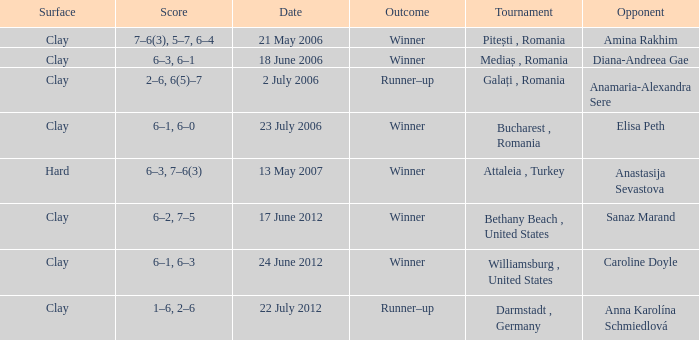Parse the full table. {'header': ['Surface', 'Score', 'Date', 'Outcome', 'Tournament', 'Opponent'], 'rows': [['Clay', '7–6(3), 5–7, 6–4', '21 May 2006', 'Winner', 'Pitești , Romania', 'Amina Rakhim'], ['Clay', '6–3, 6–1', '18 June 2006', 'Winner', 'Mediaș , Romania', 'Diana-Andreea Gae'], ['Clay', '2–6, 6(5)–7', '2 July 2006', 'Runner–up', 'Galați , Romania', 'Anamaria-Alexandra Sere'], ['Clay', '6–1, 6–0', '23 July 2006', 'Winner', 'Bucharest , Romania', 'Elisa Peth'], ['Hard', '6–3, 7–6(3)', '13 May 2007', 'Winner', 'Attaleia , Turkey', 'Anastasija Sevastova'], ['Clay', '6–2, 7–5', '17 June 2012', 'Winner', 'Bethany Beach , United States', 'Sanaz Marand'], ['Clay', '6–1, 6–3', '24 June 2012', 'Winner', 'Williamsburg , United States', 'Caroline Doyle'], ['Clay', '1–6, 2–6', '22 July 2012', 'Runner–up', 'Darmstadt , Germany', 'Anna Karolína Schmiedlová']]} What tournament was held on 21 May 2006? Pitești , Romania. 